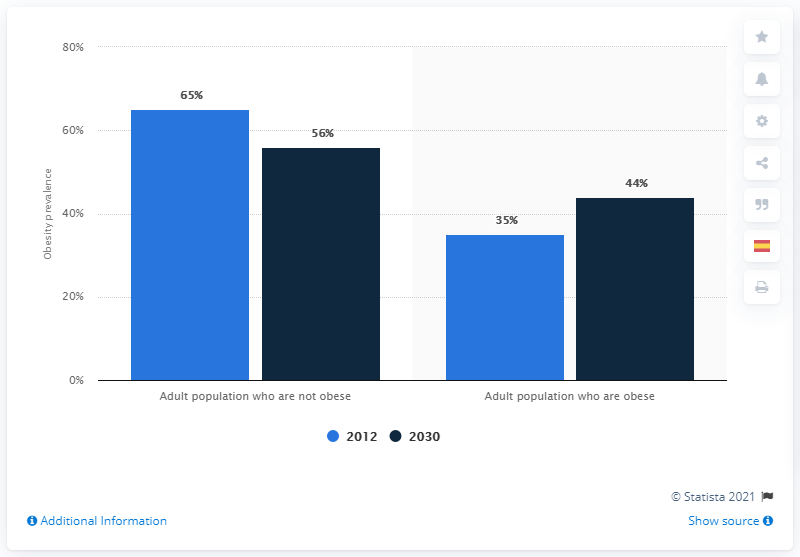Identify some key points in this picture. Obesity is predicted to be 44% of the United States adult population in the year 2030. In 2012, the prevalence of obesity among adults in the United States was prevalent. 